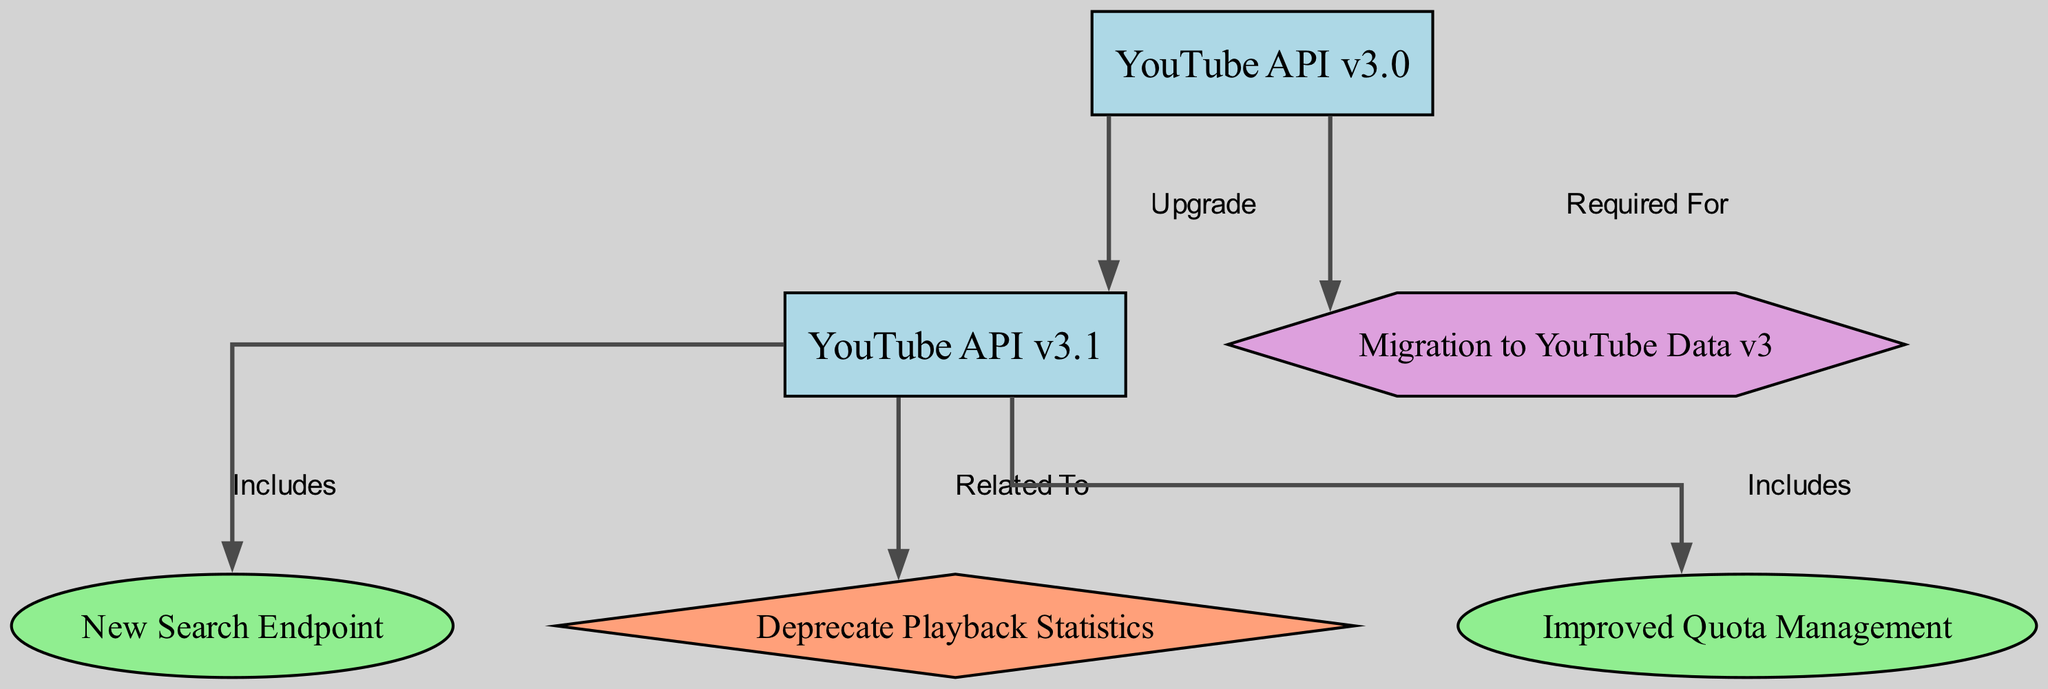What is the latest version of the YouTube API shown in the diagram? The nodes indicate that YouTube API v3.1 is present, which is the most recent version as it follows v3.0 and is the last listed version.
Answer: YouTube API v3.1 How many new features are introduced in YouTube API v3.1? By inspecting the edges pointed to from the YouTube API v3.1 node, there are two features: New Search Endpoint and Improved Quota Management.
Answer: 2 What is being deprecated in YouTube API v3.1? The edge labeled "Related To" from YouTube API v3.1 connects to the node indicating Deprecate Playback Statistics, confirming that this endpoint is being deprecated.
Answer: Deprecate Playback Statistics What is the migration requirement for upgrading to YouTube API v3.0? The edge labeled "Required For" from YouTube API v3.0 points to the Migration to YouTube Data v3, indicating this migration is a prerequisite for using v3.0.
Answer: Migration to YouTube Data v3 Which new features are included in YouTube API v3.1? By examining the edges leading from YouTube API v3.1 node, we see it includes New Search Endpoint and Improved Quota Management both labeled as "Includes".
Answer: New Search Endpoint, Improved Quota Management Which version introduced new quota management tools? The node Improved Quota Management is connected to YouTube API v3.1 by an edge labeled "Includes", which indicates that v3.1 is where this feature was introduced.
Answer: YouTube API v3.1 What type of relationships connect the nodes representing features in this diagram? The edges labeled "Includes" connect the version node v3.1 with the feature nodes, indicating inclusion, while "Related To" connects v3.1 with the deprecation, indicating a relationship of relevance.
Answer: Includes, Related To How many edges are shown in the diagram? Counting the edges listed in the edges section, there are a total of five edges connecting the various nodes within the diagram.
Answer: 5 